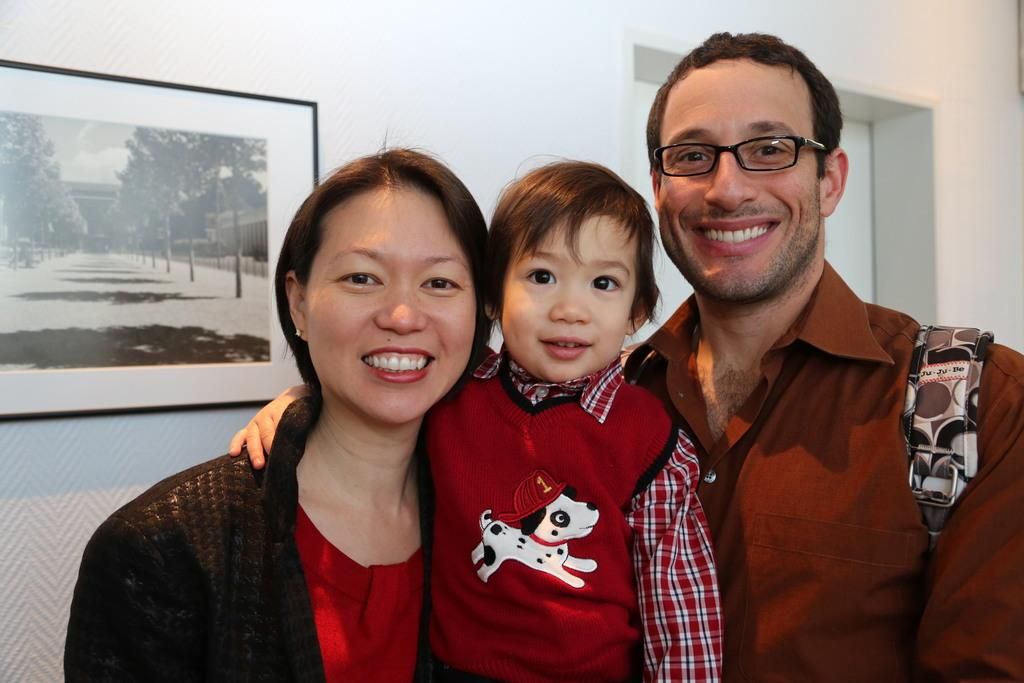What is happening in the foreground of the image? There are people standing in the foreground of the image. What can be seen in the background of the image? There appears to be a door and a frame in the background of the image. How many pets are visible in the image? There are no pets present in the image. What is the value of the dime on the door frame in the image? There is no dime present on the door frame in the image. 